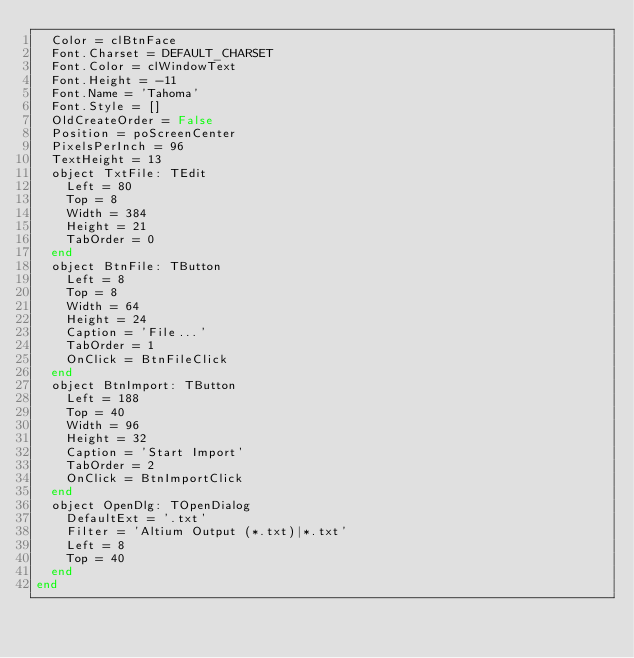Convert code to text. <code><loc_0><loc_0><loc_500><loc_500><_Pascal_>  Color = clBtnFace
  Font.Charset = DEFAULT_CHARSET
  Font.Color = clWindowText
  Font.Height = -11
  Font.Name = 'Tahoma'
  Font.Style = []
  OldCreateOrder = False
  Position = poScreenCenter
  PixelsPerInch = 96
  TextHeight = 13
  object TxtFile: TEdit
    Left = 80
    Top = 8
    Width = 384
    Height = 21
    TabOrder = 0
  end
  object BtnFile: TButton
    Left = 8
    Top = 8
    Width = 64
    Height = 24
    Caption = 'File...'
    TabOrder = 1
    OnClick = BtnFileClick
  end
  object BtnImport: TButton
    Left = 188
    Top = 40
    Width = 96
    Height = 32
    Caption = 'Start Import'
    TabOrder = 2
    OnClick = BtnImportClick
  end
  object OpenDlg: TOpenDialog
    DefaultExt = '.txt'
    Filter = 'Altium Output (*.txt)|*.txt'
    Left = 8
    Top = 40
  end
end
</code> 